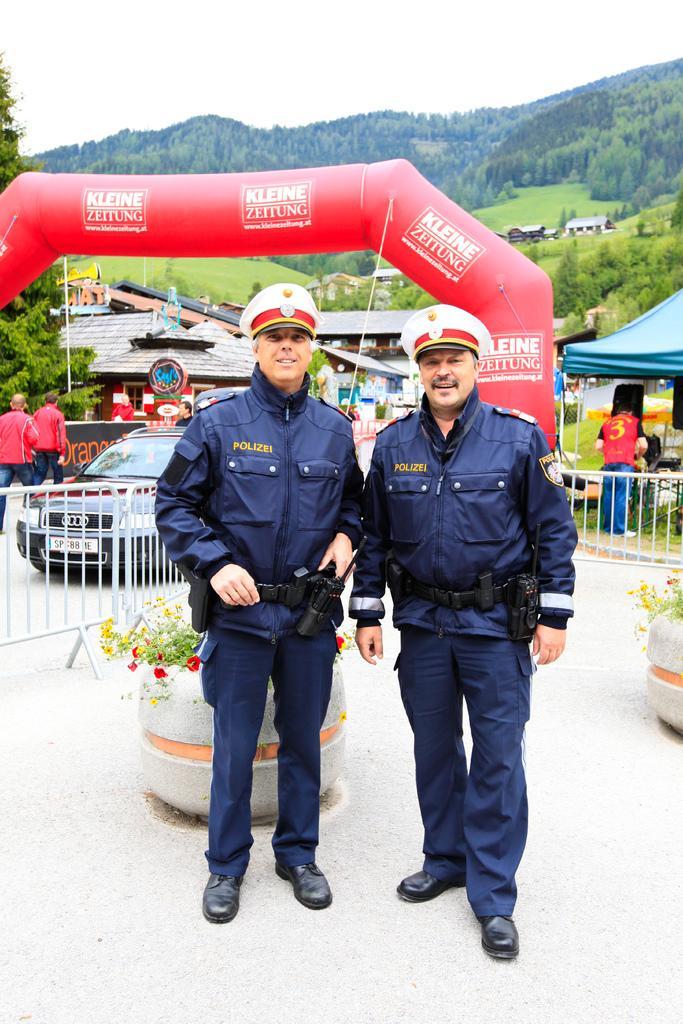Describe this image in one or two sentences. 2 cops are standing. Behind them there is a fencing, car, other people. There are tents, trees and hills at the back. 